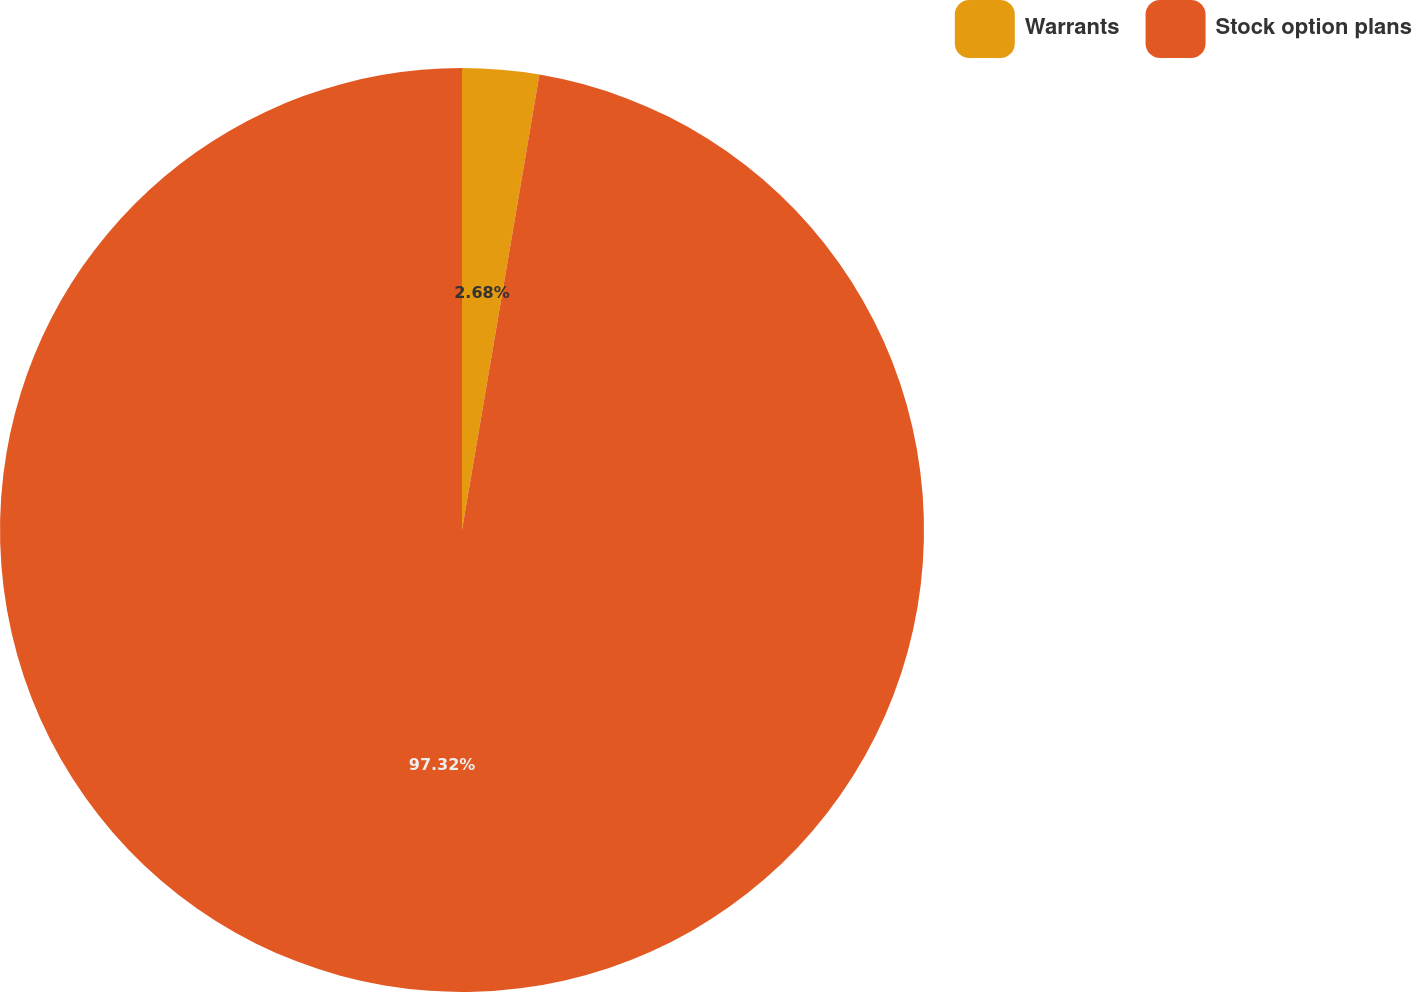Convert chart to OTSL. <chart><loc_0><loc_0><loc_500><loc_500><pie_chart><fcel>Warrants<fcel>Stock option plans<nl><fcel>2.68%<fcel>97.32%<nl></chart> 